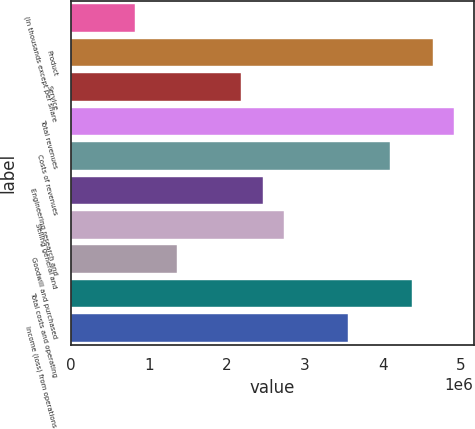Convert chart to OTSL. <chart><loc_0><loc_0><loc_500><loc_500><bar_chart><fcel>(In thousands except per share<fcel>Product<fcel>Service<fcel>Total revenues<fcel>Costs of revenues<fcel>Engineering research and<fcel>Selling general and<fcel>Goodwill and purchased<fcel>Total costs and operating<fcel>Income (loss) from operations<nl><fcel>819369<fcel>4.64309e+06<fcel>2.18498e+06<fcel>4.91621e+06<fcel>4.09684e+06<fcel>2.45811e+06<fcel>2.73123e+06<fcel>1.36561e+06<fcel>4.36997e+06<fcel>3.5506e+06<nl></chart> 